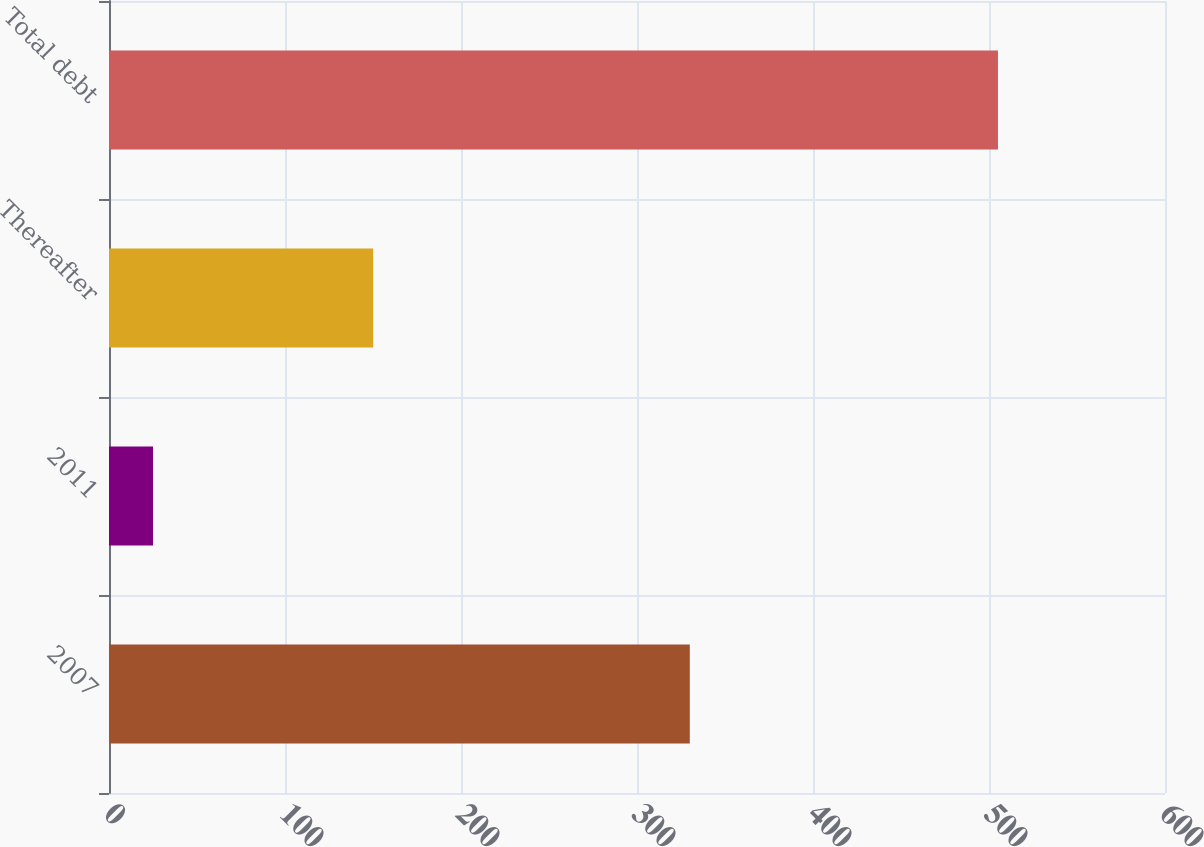<chart> <loc_0><loc_0><loc_500><loc_500><bar_chart><fcel>2007<fcel>2011<fcel>Thereafter<fcel>Total debt<nl><fcel>330<fcel>25<fcel>150.1<fcel>505.1<nl></chart> 